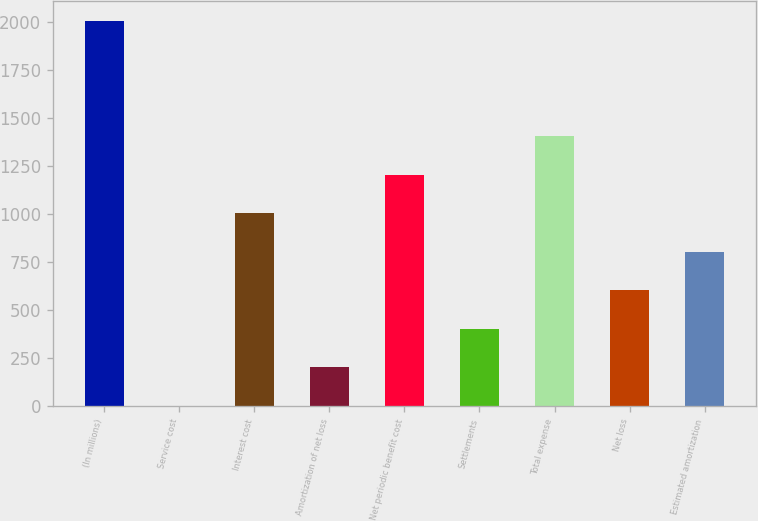Convert chart. <chart><loc_0><loc_0><loc_500><loc_500><bar_chart><fcel>(In millions)<fcel>Service cost<fcel>Interest cost<fcel>Amortization of net loss<fcel>Net periodic benefit cost<fcel>Settlements<fcel>Total expense<fcel>Net loss<fcel>Estimated amortization<nl><fcel>2009<fcel>2<fcel>1005.5<fcel>202.7<fcel>1206.2<fcel>403.4<fcel>1406.9<fcel>604.1<fcel>804.8<nl></chart> 